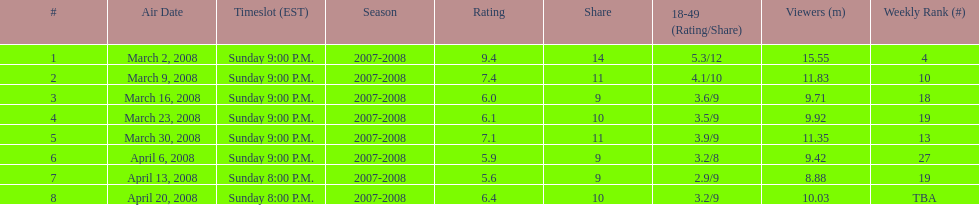For the first 6 episodes, what was the show's time slot? Sunday 9:00 P.M. 